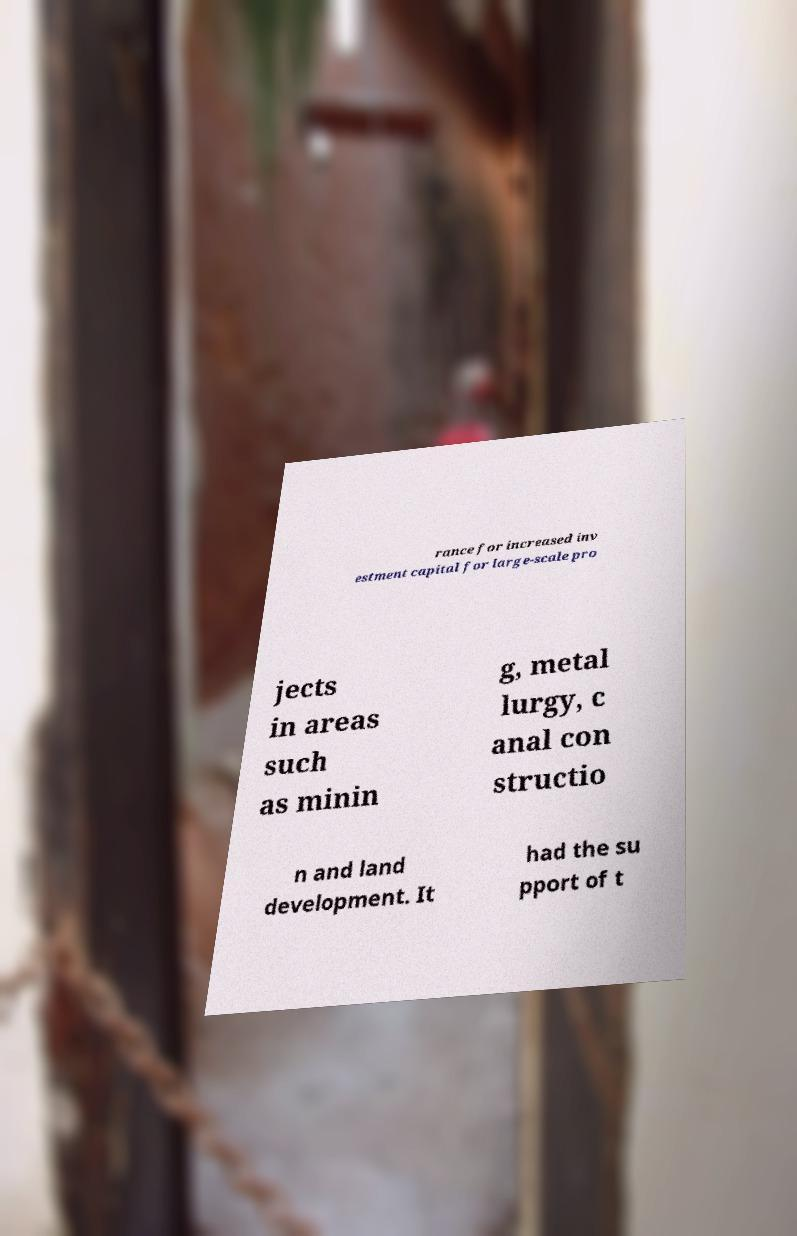Please read and relay the text visible in this image. What does it say? rance for increased inv estment capital for large-scale pro jects in areas such as minin g, metal lurgy, c anal con structio n and land development. It had the su pport of t 